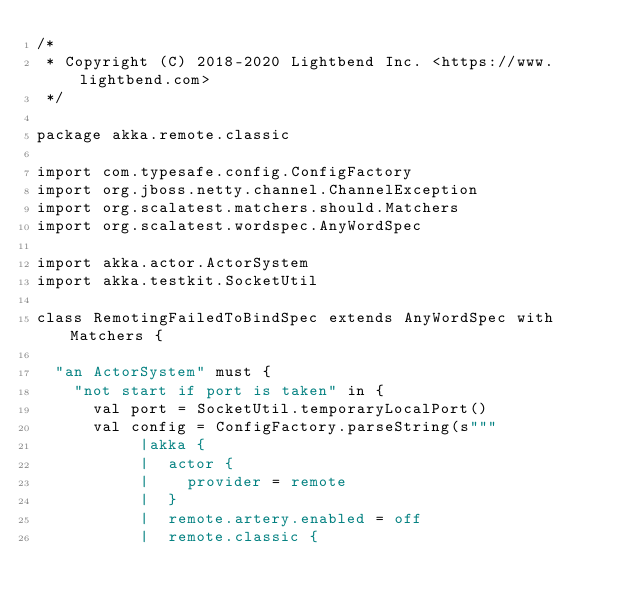<code> <loc_0><loc_0><loc_500><loc_500><_Scala_>/*
 * Copyright (C) 2018-2020 Lightbend Inc. <https://www.lightbend.com>
 */

package akka.remote.classic

import com.typesafe.config.ConfigFactory
import org.jboss.netty.channel.ChannelException
import org.scalatest.matchers.should.Matchers
import org.scalatest.wordspec.AnyWordSpec

import akka.actor.ActorSystem
import akka.testkit.SocketUtil

class RemotingFailedToBindSpec extends AnyWordSpec with Matchers {

  "an ActorSystem" must {
    "not start if port is taken" in {
      val port = SocketUtil.temporaryLocalPort()
      val config = ConfigFactory.parseString(s"""
           |akka {
           |  actor {
           |    provider = remote
           |  }
           |  remote.artery.enabled = off
           |  remote.classic {</code> 